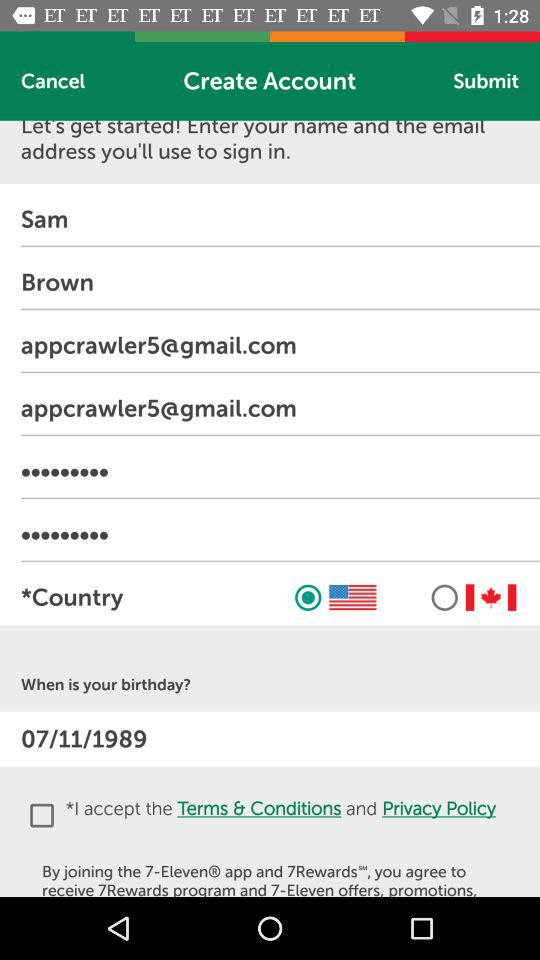What is the birth date? The birth date is November 7, 1989. 